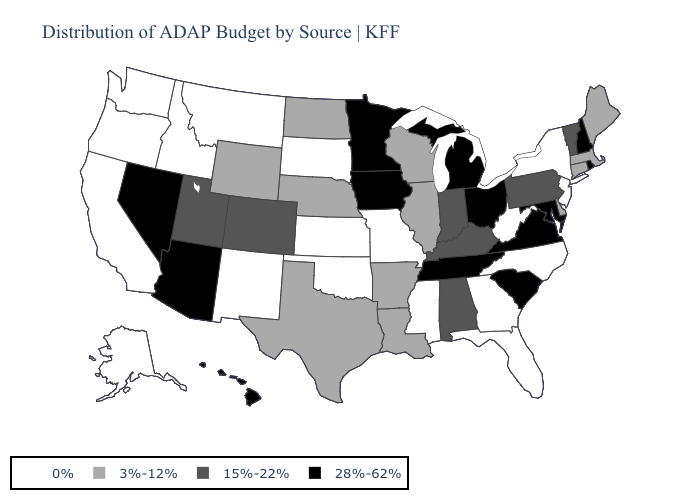What is the value of Indiana?
Write a very short answer. 15%-22%. Name the states that have a value in the range 15%-22%?
Answer briefly. Alabama, Colorado, Indiana, Kentucky, Pennsylvania, Utah, Vermont. Name the states that have a value in the range 3%-12%?
Quick response, please. Arkansas, Connecticut, Delaware, Illinois, Louisiana, Maine, Massachusetts, Nebraska, North Dakota, Texas, Wisconsin, Wyoming. Does Arizona have a lower value than Massachusetts?
Write a very short answer. No. What is the highest value in the USA?
Write a very short answer. 28%-62%. Among the states that border Texas , which have the lowest value?
Keep it brief. New Mexico, Oklahoma. Name the states that have a value in the range 0%?
Answer briefly. Alaska, California, Florida, Georgia, Idaho, Kansas, Mississippi, Missouri, Montana, New Jersey, New Mexico, New York, North Carolina, Oklahoma, Oregon, South Dakota, Washington, West Virginia. What is the lowest value in states that border Arizona?
Answer briefly. 0%. What is the value of Alabama?
Short answer required. 15%-22%. What is the lowest value in the USA?
Concise answer only. 0%. What is the lowest value in the West?
Concise answer only. 0%. Which states have the highest value in the USA?
Be succinct. Arizona, Hawaii, Iowa, Maryland, Michigan, Minnesota, Nevada, New Hampshire, Ohio, Rhode Island, South Carolina, Tennessee, Virginia. What is the value of New York?
Keep it brief. 0%. 